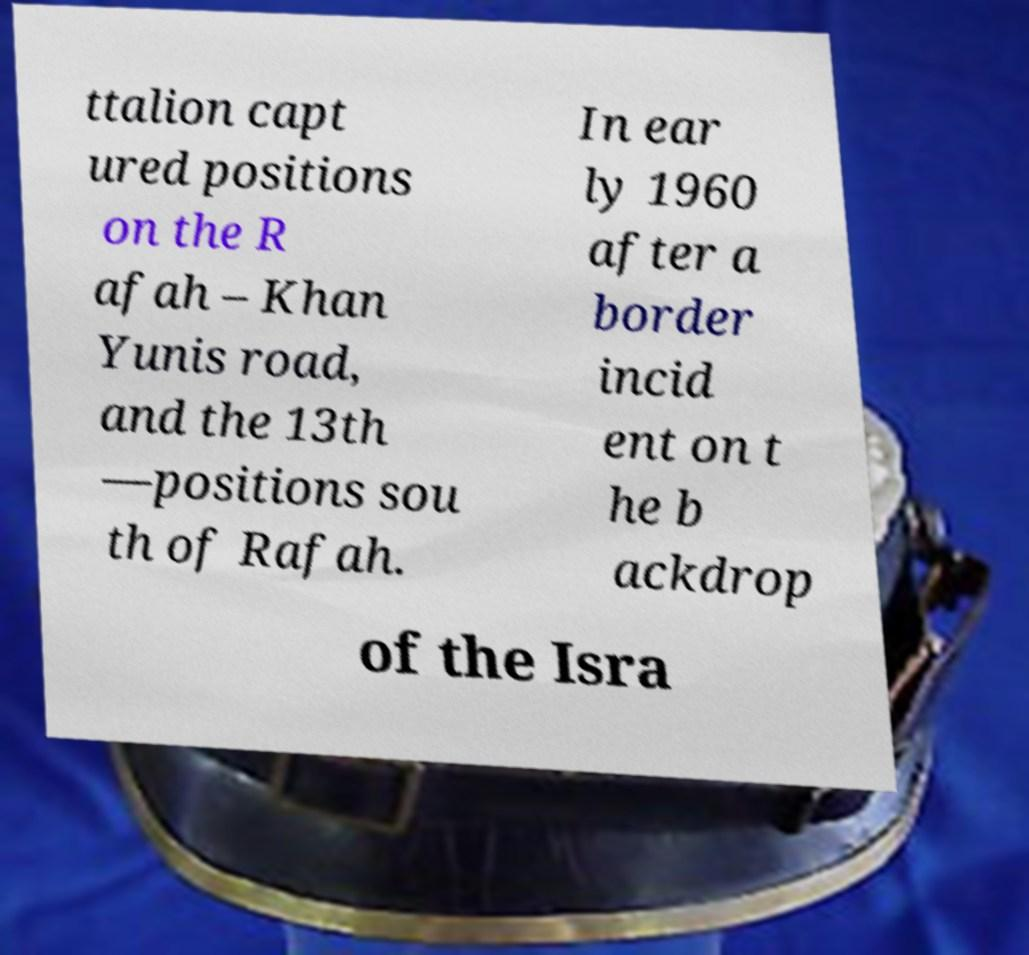Can you read and provide the text displayed in the image?This photo seems to have some interesting text. Can you extract and type it out for me? ttalion capt ured positions on the R afah – Khan Yunis road, and the 13th —positions sou th of Rafah. In ear ly 1960 after a border incid ent on t he b ackdrop of the Isra 